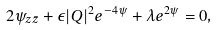Convert formula to latex. <formula><loc_0><loc_0><loc_500><loc_500>2 \psi _ { z \bar { z } } + \epsilon | Q | ^ { 2 } e ^ { - 4 \psi } + \lambda e ^ { 2 \psi } = 0 ,</formula> 